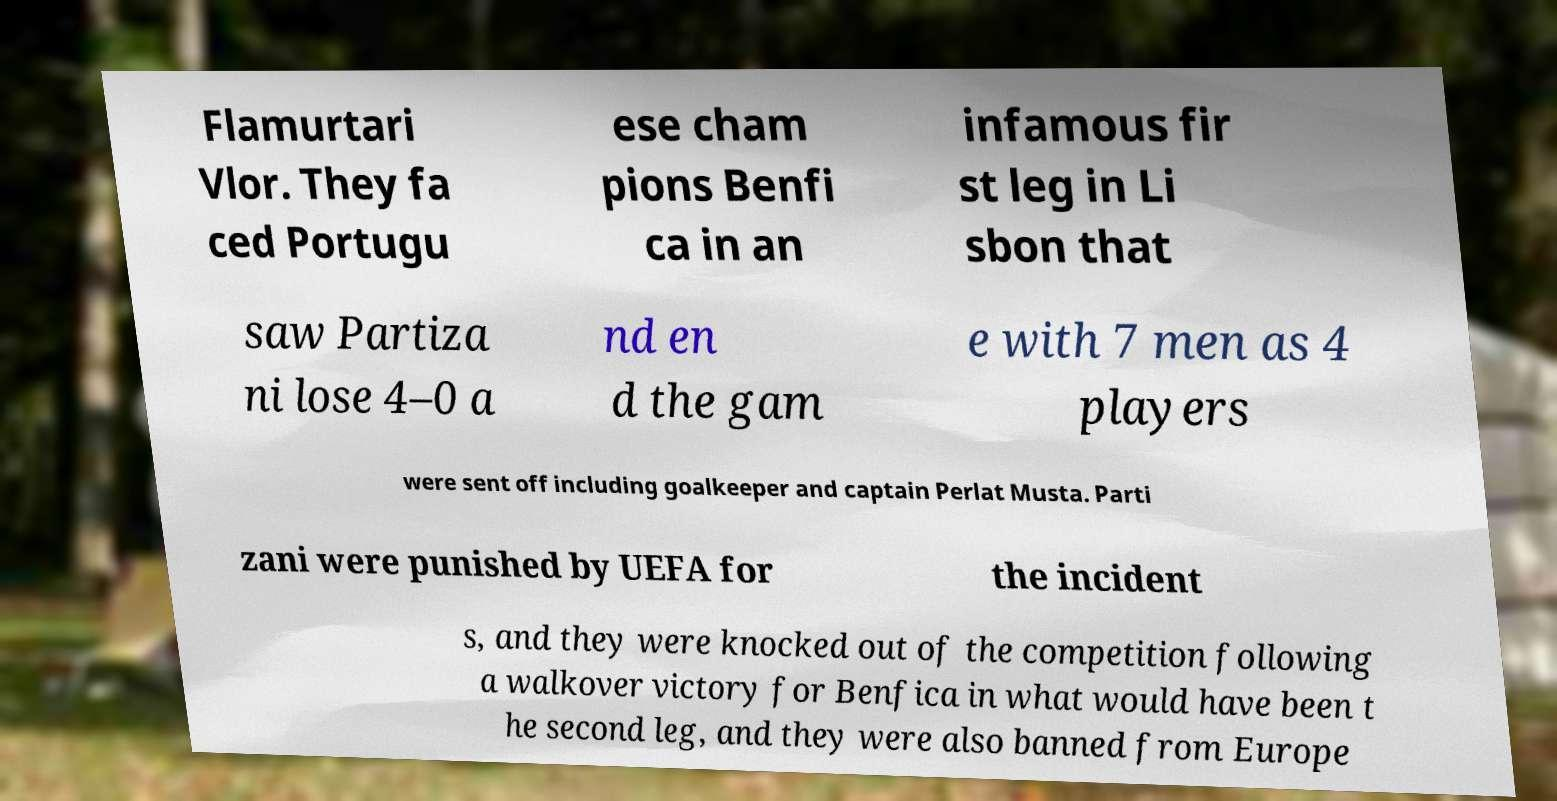Please read and relay the text visible in this image. What does it say? Flamurtari Vlor. They fa ced Portugu ese cham pions Benfi ca in an infamous fir st leg in Li sbon that saw Partiza ni lose 4–0 a nd en d the gam e with 7 men as 4 players were sent off including goalkeeper and captain Perlat Musta. Parti zani were punished by UEFA for the incident s, and they were knocked out of the competition following a walkover victory for Benfica in what would have been t he second leg, and they were also banned from Europe 